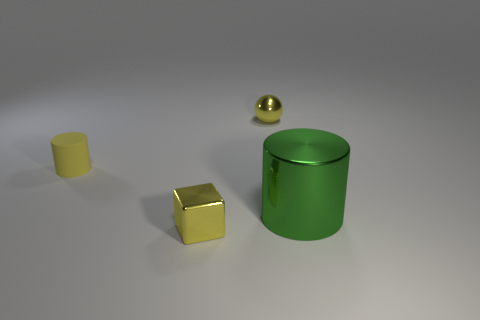Add 1 red shiny objects. How many objects exist? 5 Subtract all spheres. How many objects are left? 3 Subtract all small yellow shiny balls. Subtract all rubber objects. How many objects are left? 2 Add 3 tiny objects. How many tiny objects are left? 6 Add 3 tiny blocks. How many tiny blocks exist? 4 Subtract 0 purple spheres. How many objects are left? 4 